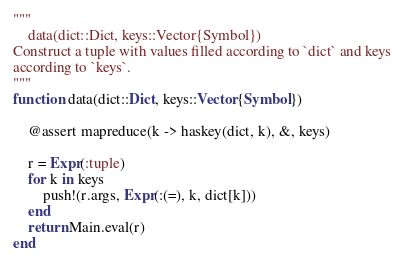Convert code to text. <code><loc_0><loc_0><loc_500><loc_500><_Julia_>"""
    data(dict::Dict, keys::Vector{Symbol})
Construct a tuple with values filled according to `dict` and keys
according to `keys`.
"""
function data(dict::Dict, keys::Vector{Symbol})

    @assert mapreduce(k -> haskey(dict, k), &, keys)

    r = Expr(:tuple)
    for k in keys
        push!(r.args, Expr(:(=), k, dict[k]))
    end
    return Main.eval(r)
end
</code> 